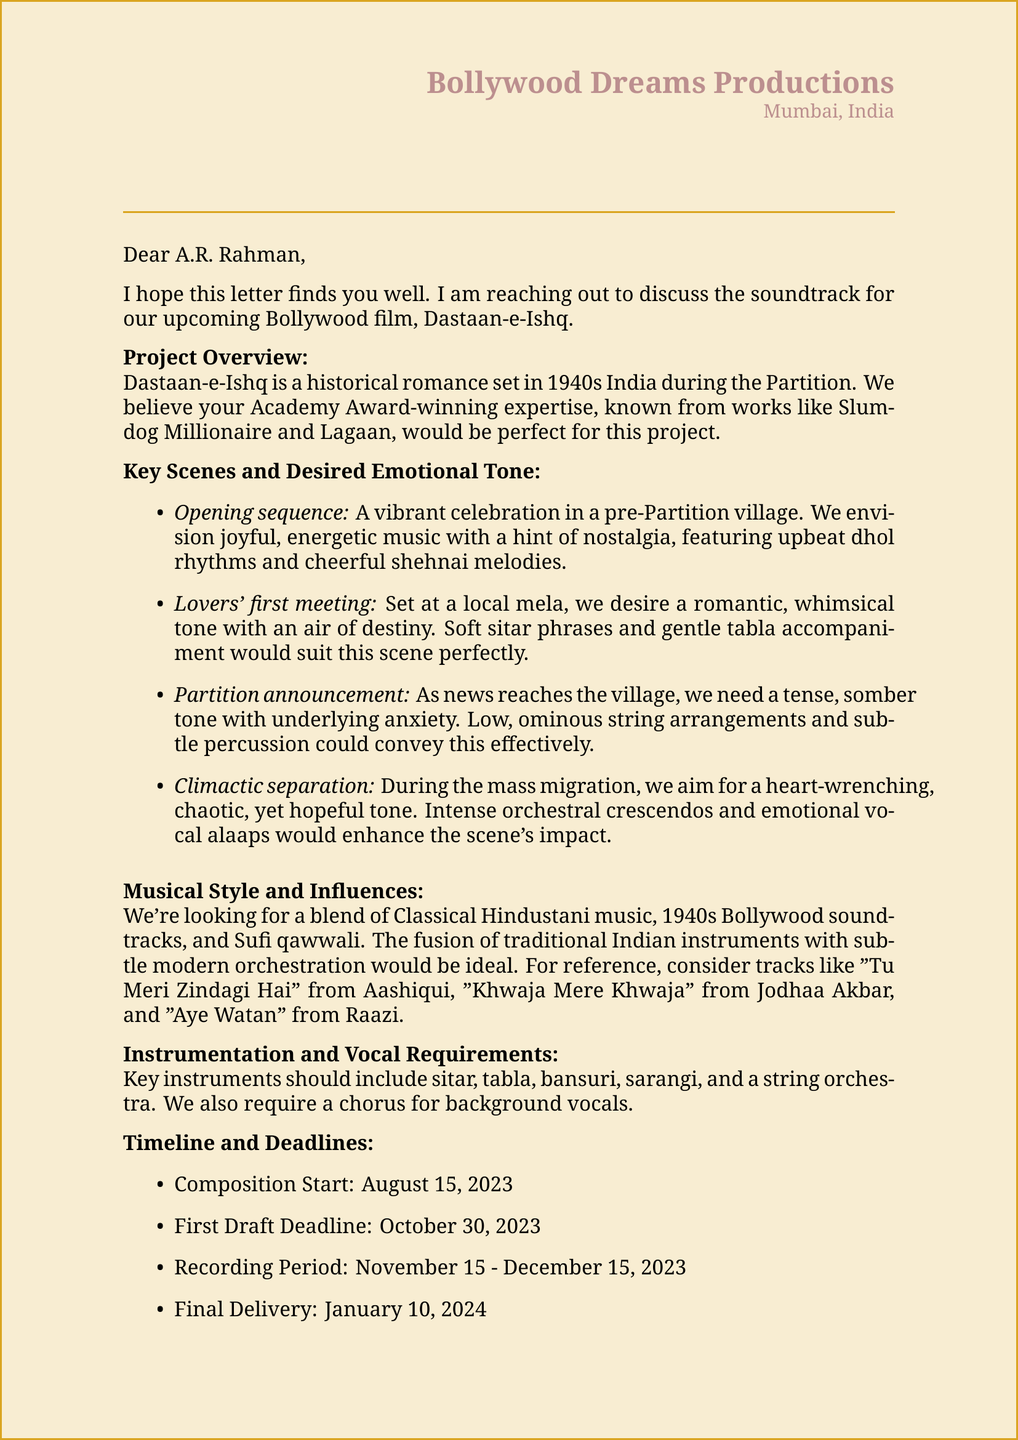What is the title of the film? The title of the film, as mentioned in the document, is Dastaan-e-Ishq.
Answer: Dastaan-e-Ishq Who is the composer addressed in the letter? The letter is specifically addressed to A.R. Rahman.
Answer: A.R. Rahman What is the genre of Dastaan-e-Ishq? The document specifies that the genre of the film is historical romance.
Answer: Historical romance What is the desired tone for the opening sequence? The document states that a joyful, energetic tone with a hint of nostalgia is desired for the opening sequence.
Answer: Joyful, energetic, with a hint of nostalgia When is the first draft deadline? According to the document, the first draft deadline is set for October 30, 2023.
Answer: October 30, 2023 What instrumentation is required for the soundtrack? The document lists several instruments, including sitar, tabla, and bansuri, as part of the instrumentation requirements.
Answer: Sitar, tabla, bansuri How will collaboration progress be reviewed? The document mentions regular updates through weekly video calls to review progress.
Answer: Weekly video calls What is the main influence for the musical style? The document identifies Classical Hindustani music as one of the primary influences for the musical style.
Answer: Classical Hindustani music What is the setting of the film? The setting of the film, as mentioned in the document, is 1940s India during the Partition.
Answer: 1940s India during the Partition 